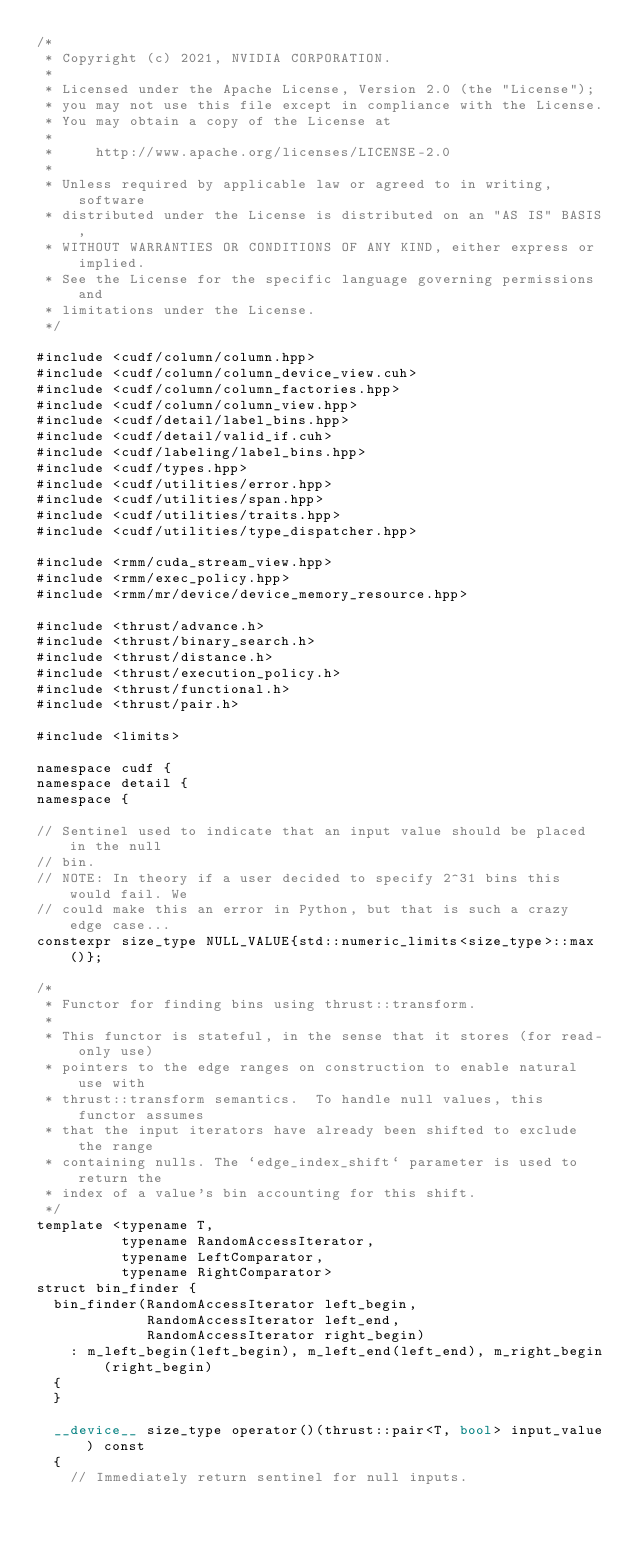<code> <loc_0><loc_0><loc_500><loc_500><_Cuda_>/*
 * Copyright (c) 2021, NVIDIA CORPORATION.
 *
 * Licensed under the Apache License, Version 2.0 (the "License");
 * you may not use this file except in compliance with the License.
 * You may obtain a copy of the License at
 *
 *     http://www.apache.org/licenses/LICENSE-2.0
 *
 * Unless required by applicable law or agreed to in writing, software
 * distributed under the License is distributed on an "AS IS" BASIS,
 * WITHOUT WARRANTIES OR CONDITIONS OF ANY KIND, either express or implied.
 * See the License for the specific language governing permissions and
 * limitations under the License.
 */

#include <cudf/column/column.hpp>
#include <cudf/column/column_device_view.cuh>
#include <cudf/column/column_factories.hpp>
#include <cudf/column/column_view.hpp>
#include <cudf/detail/label_bins.hpp>
#include <cudf/detail/valid_if.cuh>
#include <cudf/labeling/label_bins.hpp>
#include <cudf/types.hpp>
#include <cudf/utilities/error.hpp>
#include <cudf/utilities/span.hpp>
#include <cudf/utilities/traits.hpp>
#include <cudf/utilities/type_dispatcher.hpp>

#include <rmm/cuda_stream_view.hpp>
#include <rmm/exec_policy.hpp>
#include <rmm/mr/device/device_memory_resource.hpp>

#include <thrust/advance.h>
#include <thrust/binary_search.h>
#include <thrust/distance.h>
#include <thrust/execution_policy.h>
#include <thrust/functional.h>
#include <thrust/pair.h>

#include <limits>

namespace cudf {
namespace detail {
namespace {

// Sentinel used to indicate that an input value should be placed in the null
// bin.
// NOTE: In theory if a user decided to specify 2^31 bins this would fail. We
// could make this an error in Python, but that is such a crazy edge case...
constexpr size_type NULL_VALUE{std::numeric_limits<size_type>::max()};

/*
 * Functor for finding bins using thrust::transform.
 *
 * This functor is stateful, in the sense that it stores (for read-only use)
 * pointers to the edge ranges on construction to enable natural use with
 * thrust::transform semantics.  To handle null values, this functor assumes
 * that the input iterators have already been shifted to exclude the range
 * containing nulls. The `edge_index_shift` parameter is used to return the
 * index of a value's bin accounting for this shift.
 */
template <typename T,
          typename RandomAccessIterator,
          typename LeftComparator,
          typename RightComparator>
struct bin_finder {
  bin_finder(RandomAccessIterator left_begin,
             RandomAccessIterator left_end,
             RandomAccessIterator right_begin)
    : m_left_begin(left_begin), m_left_end(left_end), m_right_begin(right_begin)
  {
  }

  __device__ size_type operator()(thrust::pair<T, bool> input_value) const
  {
    // Immediately return sentinel for null inputs.</code> 